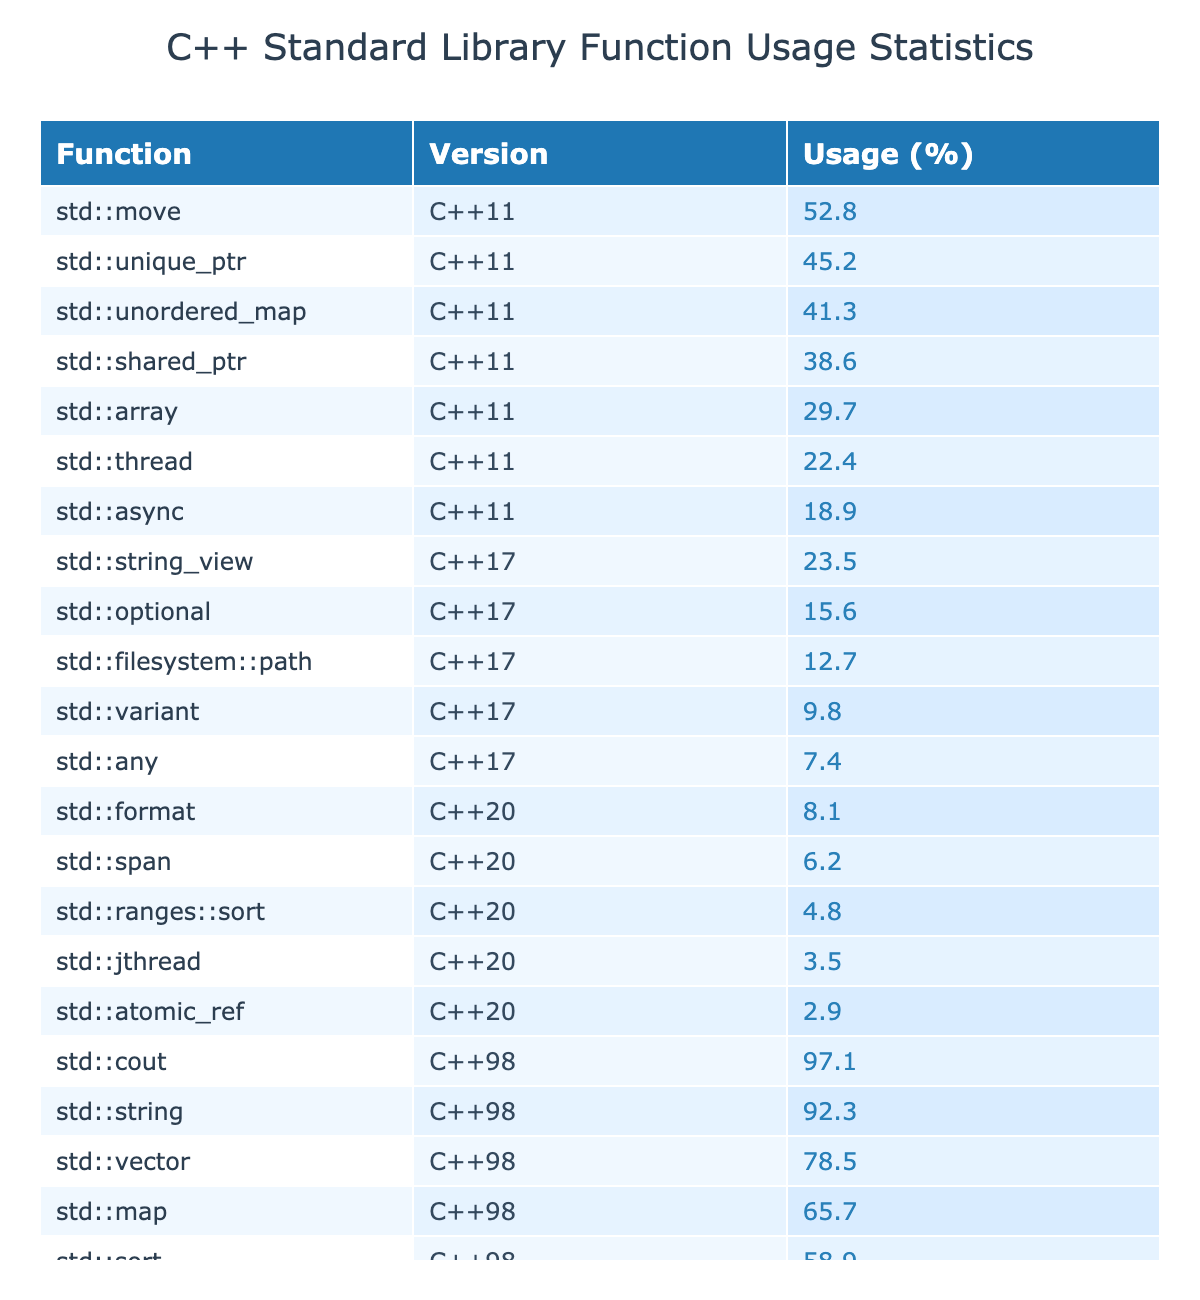What is the usage percentage of std::string in C++98? The table shows that the usage percentage of std::string in C++98 is 92.3%.
Answer: 92.3% Which function had the lowest usage in C++17? Looking at the data for C++17, std::any has the lowest usage percentage at 7.4%.
Answer: 7.4% What is the average usage percentage of functions in C++11? The percentages for C++11 functions are 45.2, 38.6, 52.8, 29.7, 22.4, 41.3, and 18.9. Summing these gives 249.1, which divided by 7 (the number of functions) results in an average of approximately 35.6%.
Answer: 35.6% Is std::sort more popular than std::unordered_map in C++11? In C++11, std::sort has a usage percentage of 58.9%, while std::unordered_map has 41.3%. Since 58.9% is greater than 41.3%, std::sort is indeed more popular.
Answer: Yes How many functions in C++20 have a usage percentage below 10%? The functions in C++20 are std::span (6.2%), std::ranges::sort (4.8%), and std::atomic_ref (2.9%). Therefore, there are three functions with usage percentages below 10%.
Answer: 3 What percentage of functions in C++98 had a usage of over 90%? The functions in C++98 are std::string (92.3%), std::cout (97.1%), std::vector (78.5%), std::map (65.7%), and std::sort (58.9%). The functions with over 90% usage are std::string and std::cout, which gives 2 out of 5 functions. Therefore, 2/5 equals 40%.
Answer: 40% Which version has the highest overall usage of functions? By examining the usage percentages, C++98 functions mostly exceed 90%, including std::string and std::cout, but C++11 and C++17 have lower maximums (52.8% and 23.5% respectively). Consequently, C++98 has the highest overall usage of functions.
Answer: C++98 What is the total usage percentage for all functions in the table? To find the total usage percentage, sum all the usage percentages: 78.5 + 92.3 + 65.7 + 97.1 + 58.9 + 45.2 + 38.6 + 52.8 + 29.7 + 22.4 + 41.3 + 18.9 + 15.6 + 9.8 + 23.5 + 12.7 + 7.4 + 6.2 + 4.8 + 8.1 + 3.5 + 2.9 = 649.3%.
Answer: 649.3% Which function maintains a usage percentage of at least 50% across all versions? From the data, the functions with usage percentages of at least 50% are std::vector (78.5% in C++98), std::string (92.3% in C++98), std::cout (97.1% in C++98), std::sort (58.9% in C++98), but none in later versions, as all functions decrease below this mark. Hence, no function maintains at least 50% in more than one version.
Answer: None 